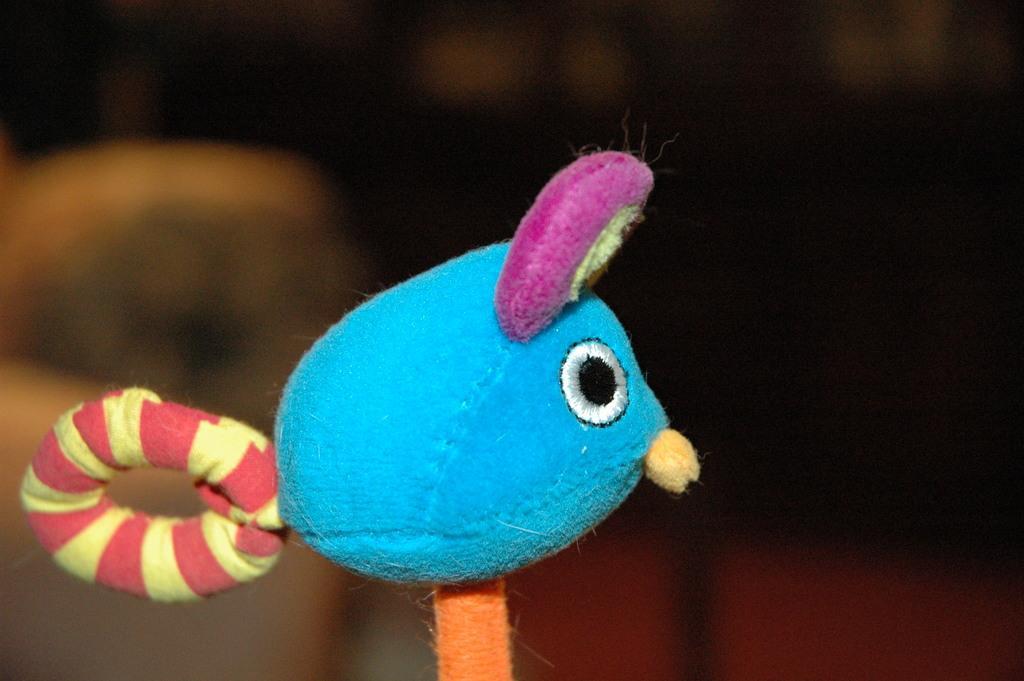Describe this image in one or two sentences. In the image there is a toy in the front and the background is blurry. 